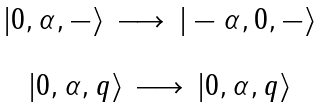Convert formula to latex. <formula><loc_0><loc_0><loc_500><loc_500>\begin{array} { c } | 0 , \alpha , - \rangle \, \longrightarrow \, | - \alpha , 0 , - \rangle \\ \\ | 0 , \alpha , q \rangle \, \longrightarrow \, | 0 , \alpha , q \rangle \end{array}</formula> 